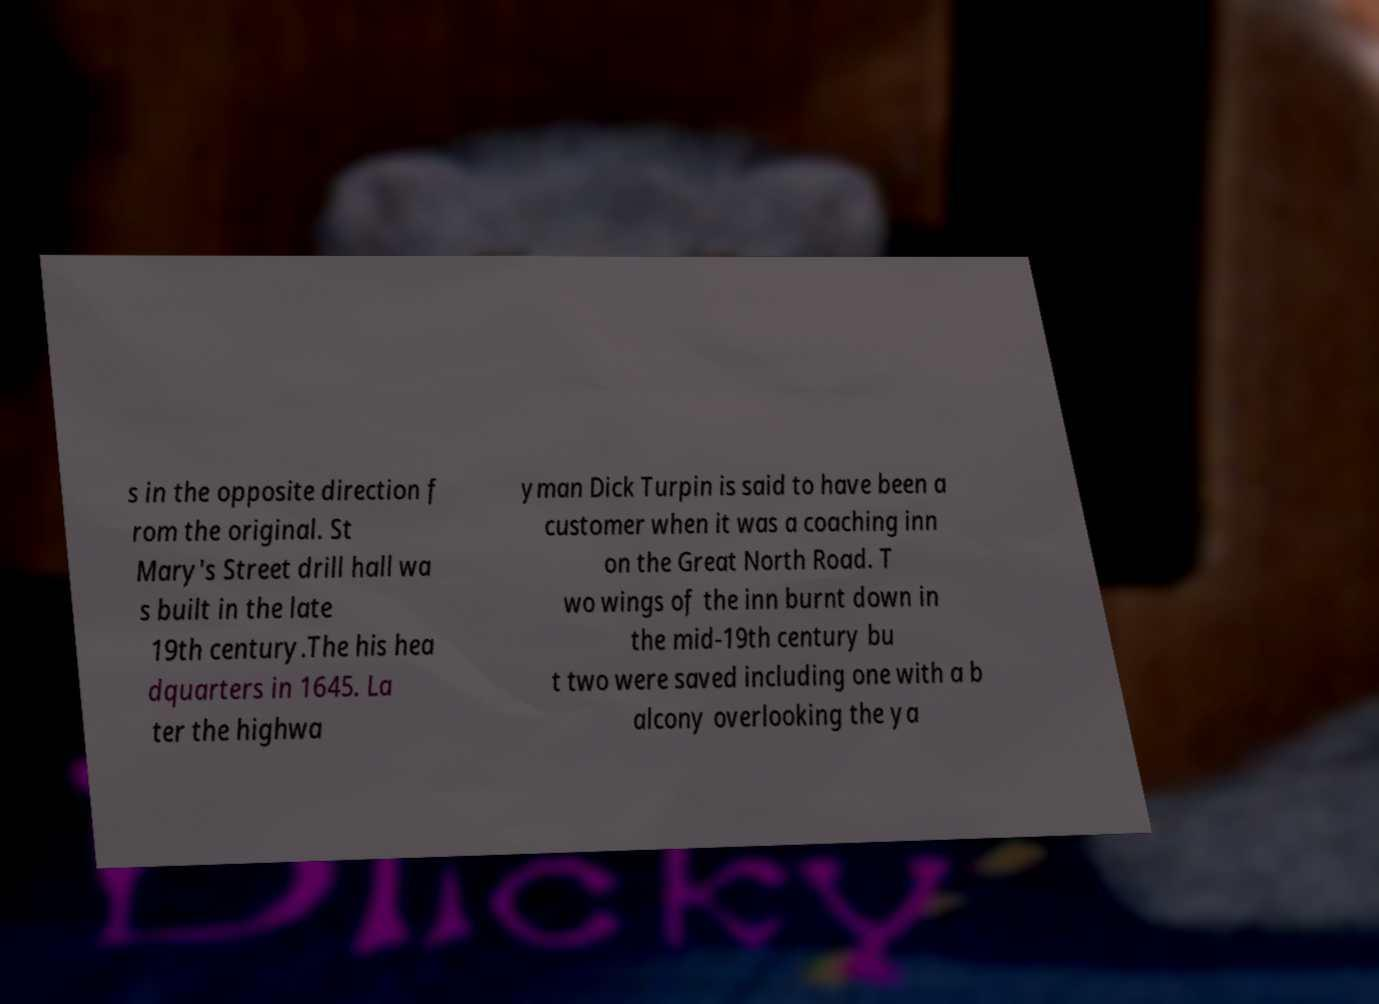Please identify and transcribe the text found in this image. s in the opposite direction f rom the original. St Mary's Street drill hall wa s built in the late 19th century.The his hea dquarters in 1645. La ter the highwa yman Dick Turpin is said to have been a customer when it was a coaching inn on the Great North Road. T wo wings of the inn burnt down in the mid-19th century bu t two were saved including one with a b alcony overlooking the ya 